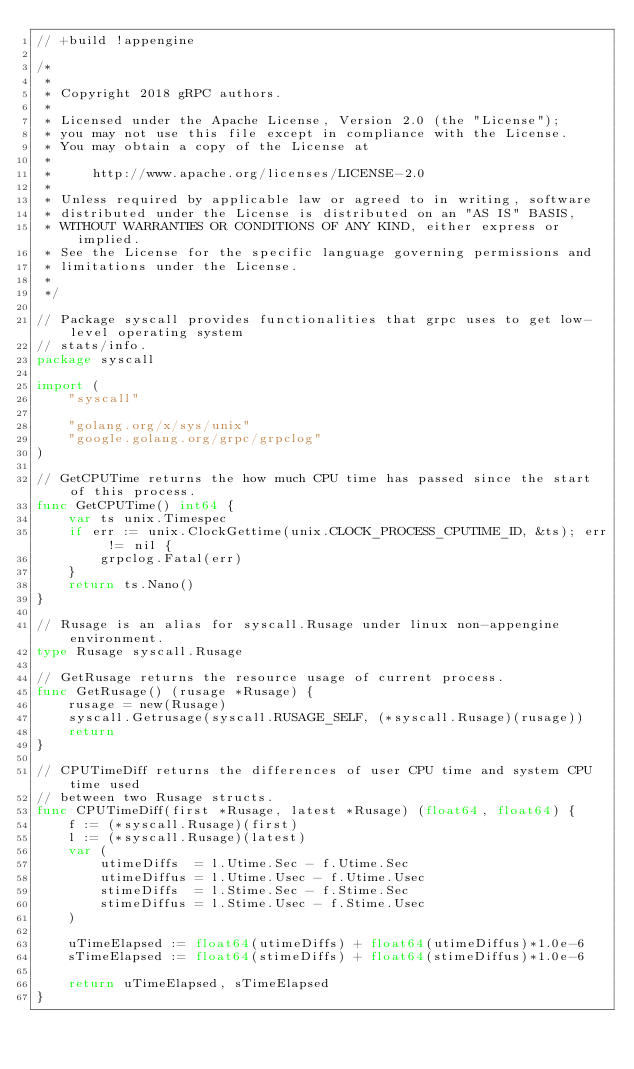Convert code to text. <code><loc_0><loc_0><loc_500><loc_500><_Go_>// +build !appengine

/*
 *
 * Copyright 2018 gRPC authors.
 *
 * Licensed under the Apache License, Version 2.0 (the "License");
 * you may not use this file except in compliance with the License.
 * You may obtain a copy of the License at
 *
 *     http://www.apache.org/licenses/LICENSE-2.0
 *
 * Unless required by applicable law or agreed to in writing, software
 * distributed under the License is distributed on an "AS IS" BASIS,
 * WITHOUT WARRANTIES OR CONDITIONS OF ANY KIND, either express or implied.
 * See the License for the specific language governing permissions and
 * limitations under the License.
 *
 */

// Package syscall provides functionalities that grpc uses to get low-level operating system
// stats/info.
package syscall

import (
	"syscall"

	"golang.org/x/sys/unix"
	"google.golang.org/grpc/grpclog"
)

// GetCPUTime returns the how much CPU time has passed since the start of this process.
func GetCPUTime() int64 {
	var ts unix.Timespec
	if err := unix.ClockGettime(unix.CLOCK_PROCESS_CPUTIME_ID, &ts); err != nil {
		grpclog.Fatal(err)
	}
	return ts.Nano()
}

// Rusage is an alias for syscall.Rusage under linux non-appengine environment.
type Rusage syscall.Rusage

// GetRusage returns the resource usage of current process.
func GetRusage() (rusage *Rusage) {
	rusage = new(Rusage)
	syscall.Getrusage(syscall.RUSAGE_SELF, (*syscall.Rusage)(rusage))
	return
}

// CPUTimeDiff returns the differences of user CPU time and system CPU time used
// between two Rusage structs.
func CPUTimeDiff(first *Rusage, latest *Rusage) (float64, float64) {
	f := (*syscall.Rusage)(first)
	l := (*syscall.Rusage)(latest)
	var (
		utimeDiffs  = l.Utime.Sec - f.Utime.Sec
		utimeDiffus = l.Utime.Usec - f.Utime.Usec
		stimeDiffs  = l.Stime.Sec - f.Stime.Sec
		stimeDiffus = l.Stime.Usec - f.Stime.Usec
	)

	uTimeElapsed := float64(utimeDiffs) + float64(utimeDiffus)*1.0e-6
	sTimeElapsed := float64(stimeDiffs) + float64(stimeDiffus)*1.0e-6

	return uTimeElapsed, sTimeElapsed
}
</code> 